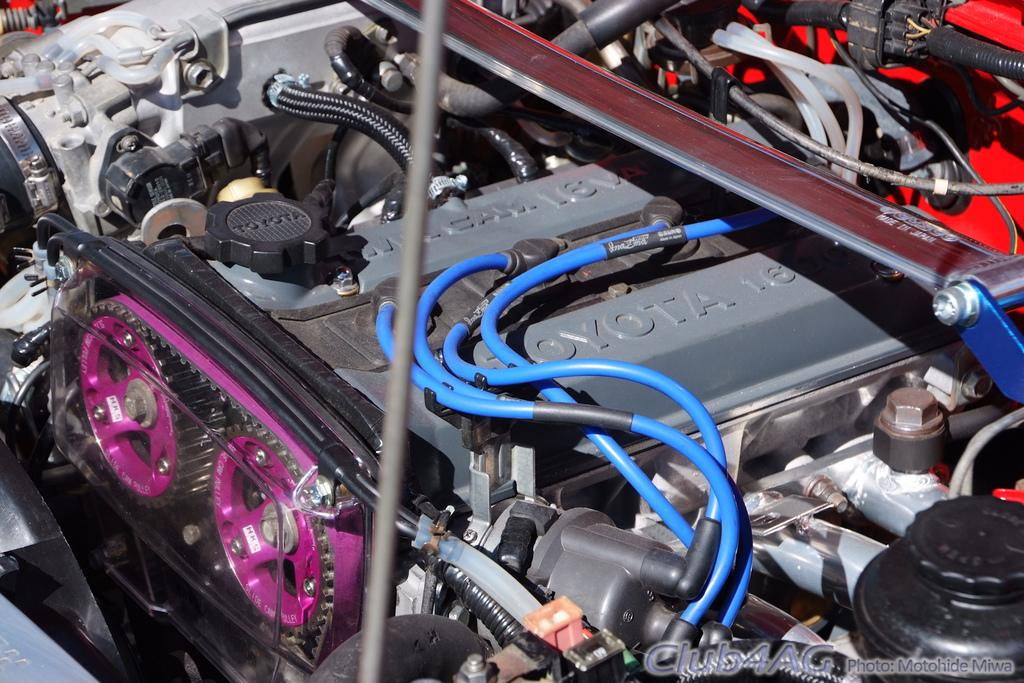What is the main subject of the image? The main subject of the image is an engine. To which type of machine does the engine belong? The engine belongs to a vehicle. What else can be seen in the image besides the engine? There are many wires visible in the image. What type of quartz is used as a decorative element in the engine? There is no quartz present in the image, as it is focused on the engine and wires of a vehicle. 